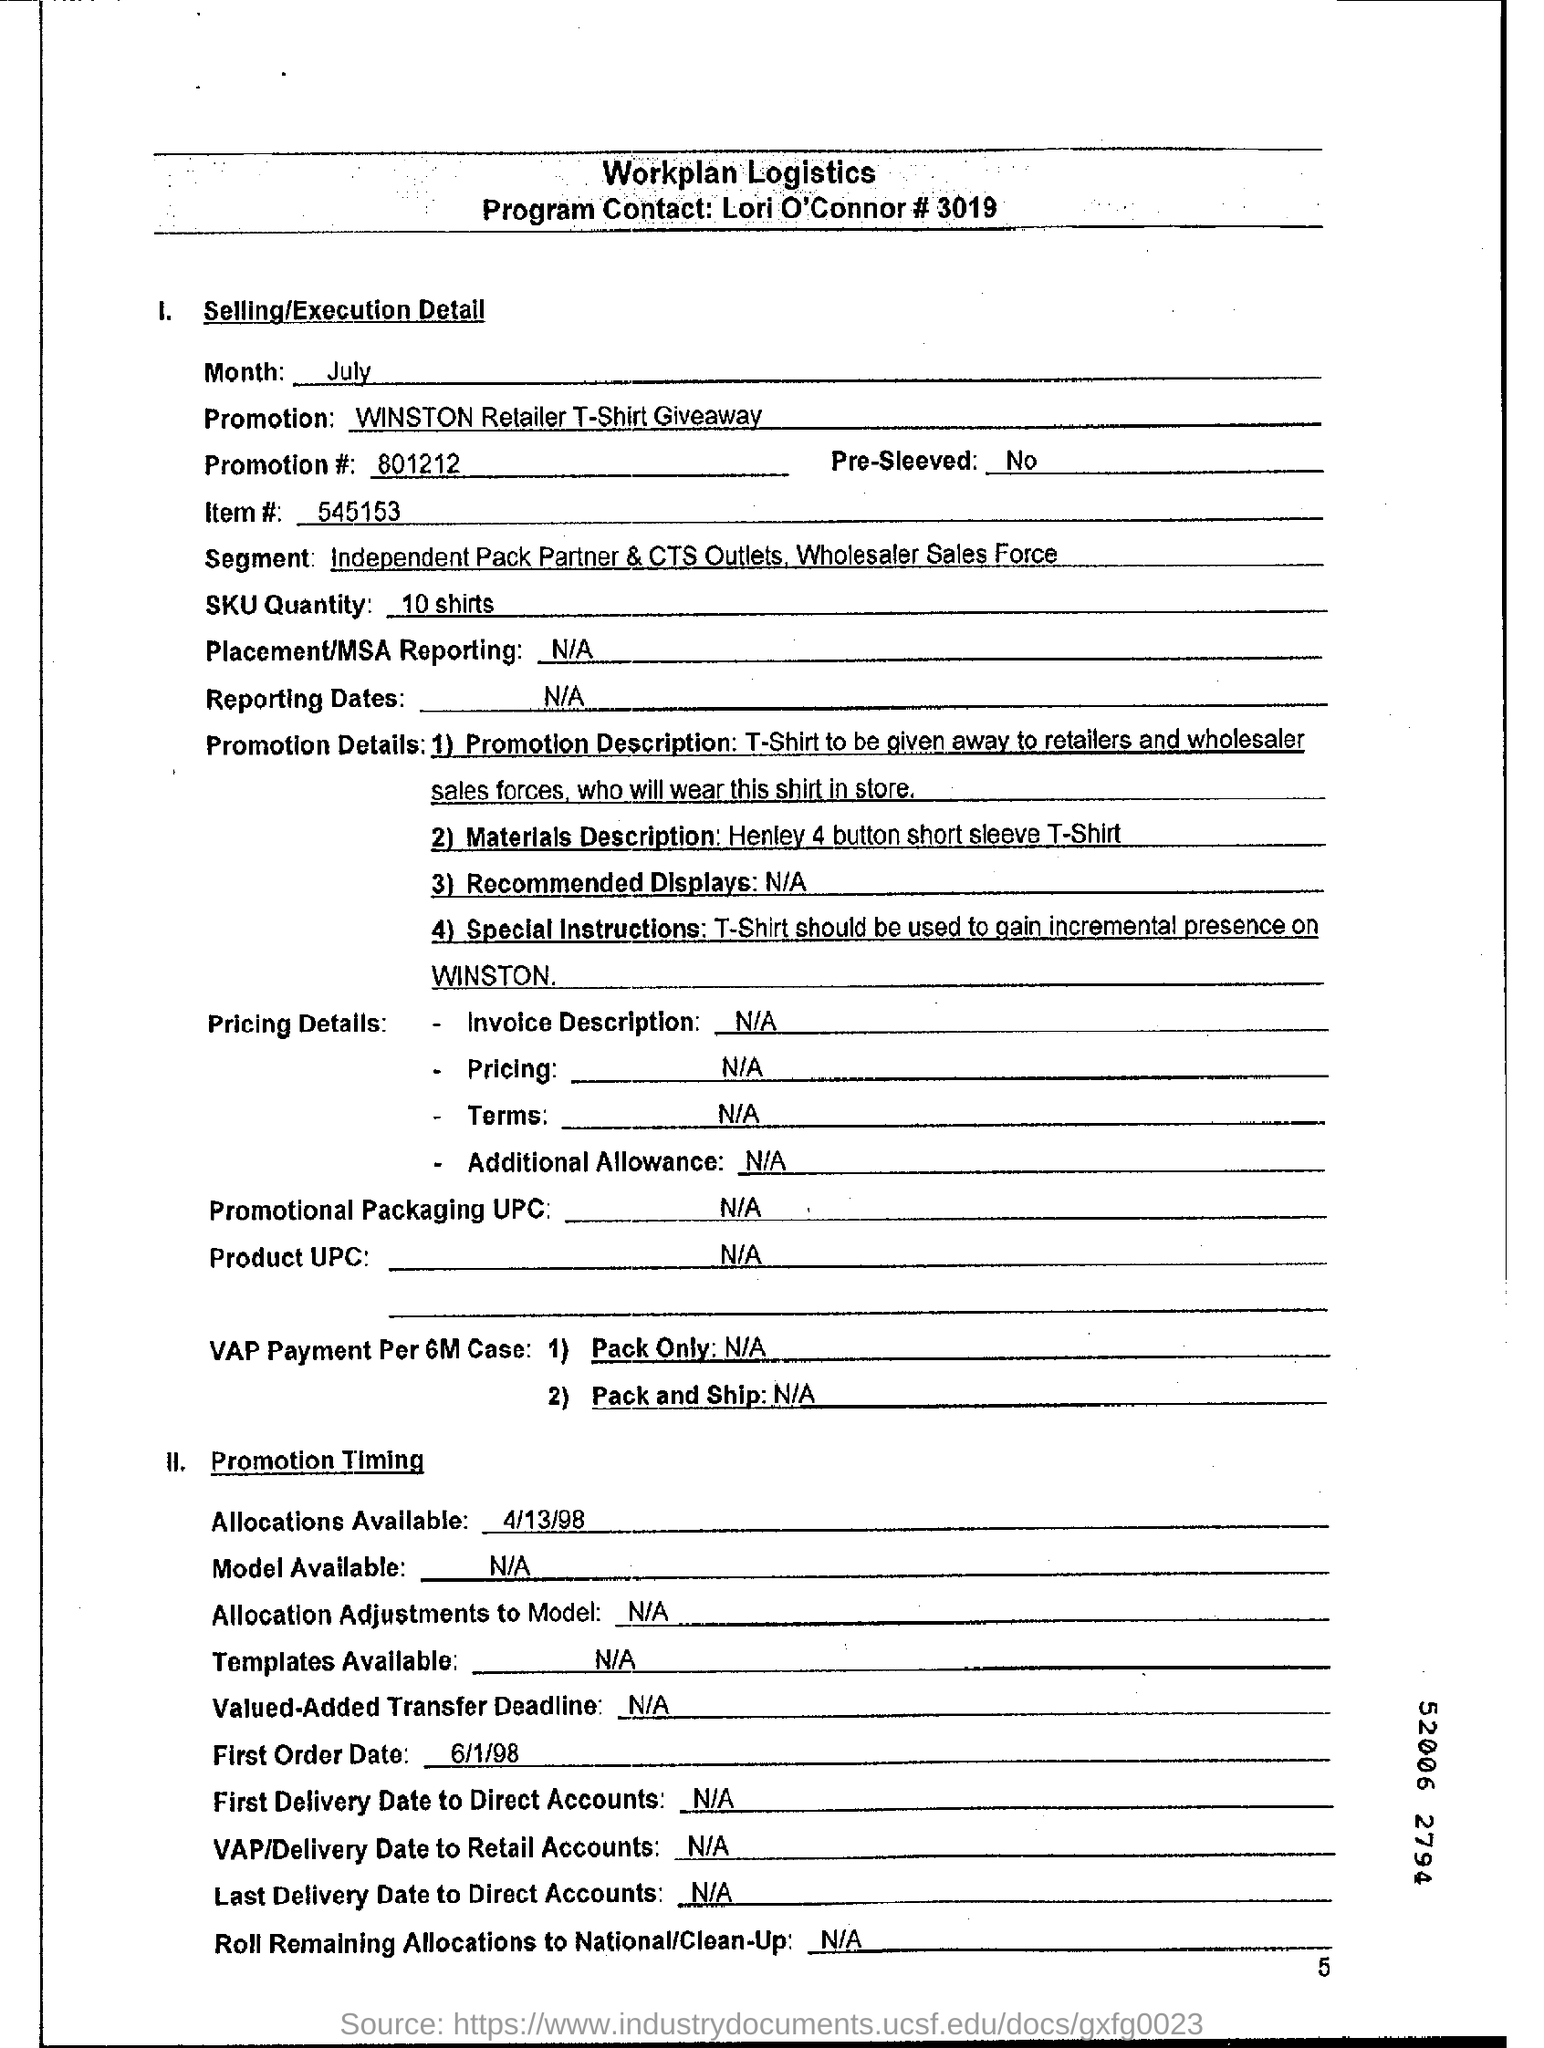When is the allocation available?
Your response must be concise. 4/13/98. How many number of promotion details are available?
Keep it short and to the point. 4. What is the first order date?
Make the answer very short. 6/1/98. 